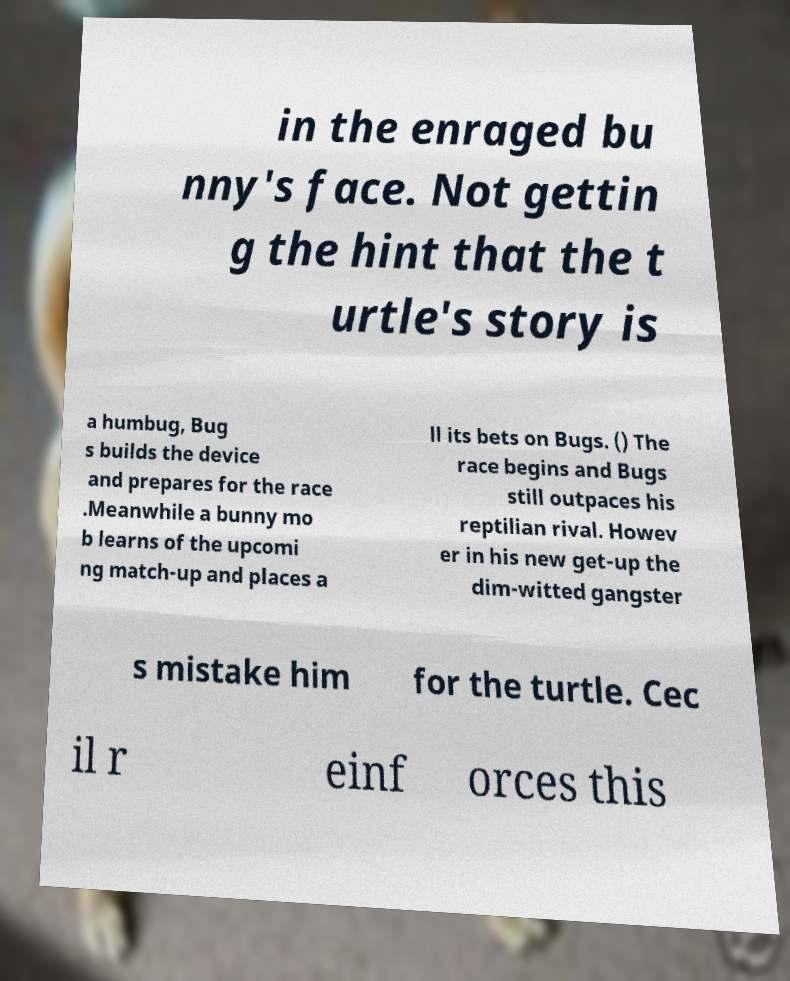Can you accurately transcribe the text from the provided image for me? in the enraged bu nny's face. Not gettin g the hint that the t urtle's story is a humbug, Bug s builds the device and prepares for the race .Meanwhile a bunny mo b learns of the upcomi ng match-up and places a ll its bets on Bugs. () The race begins and Bugs still outpaces his reptilian rival. Howev er in his new get-up the dim-witted gangster s mistake him for the turtle. Cec il r einf orces this 